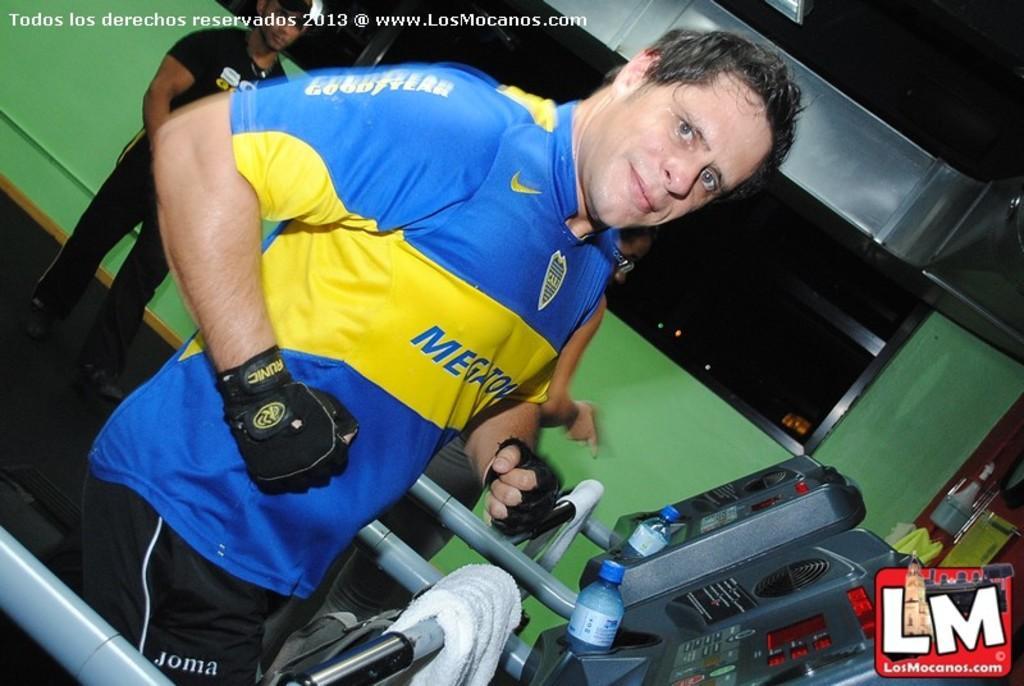Could you give a brief overview of what you see in this image? At the bottom of the image we can see treadmills. In the center there is a man running on the treadmill. In the background there is a man standing. We can see bottles and napkins and there is a wall. 